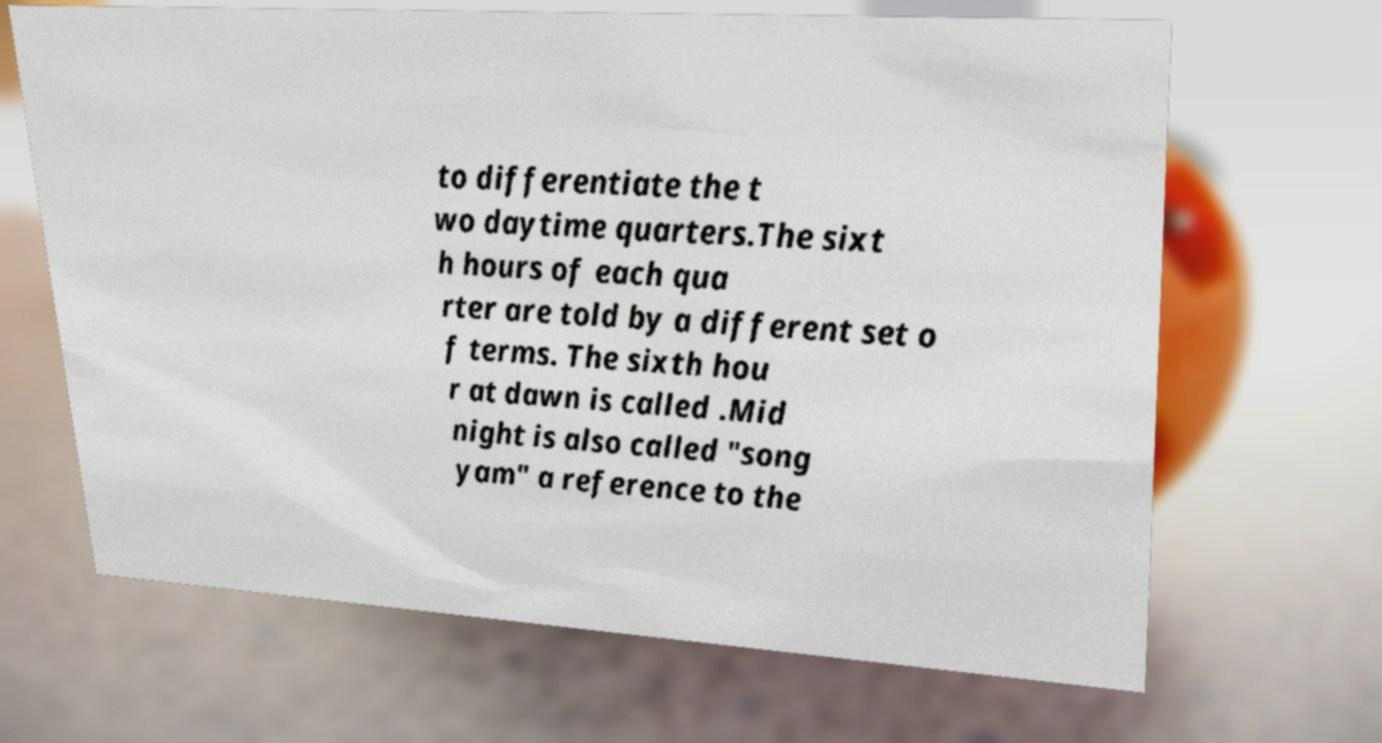I need the written content from this picture converted into text. Can you do that? to differentiate the t wo daytime quarters.The sixt h hours of each qua rter are told by a different set o f terms. The sixth hou r at dawn is called .Mid night is also called "song yam" a reference to the 